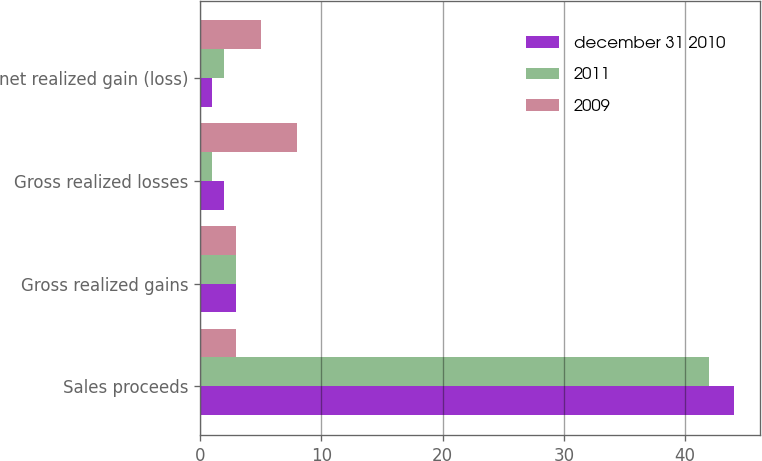Convert chart. <chart><loc_0><loc_0><loc_500><loc_500><stacked_bar_chart><ecel><fcel>Sales proceeds<fcel>Gross realized gains<fcel>Gross realized losses<fcel>net realized gain (loss)<nl><fcel>december 31 2010<fcel>44<fcel>3<fcel>2<fcel>1<nl><fcel>2011<fcel>42<fcel>3<fcel>1<fcel>2<nl><fcel>2009<fcel>3<fcel>3<fcel>8<fcel>5<nl></chart> 